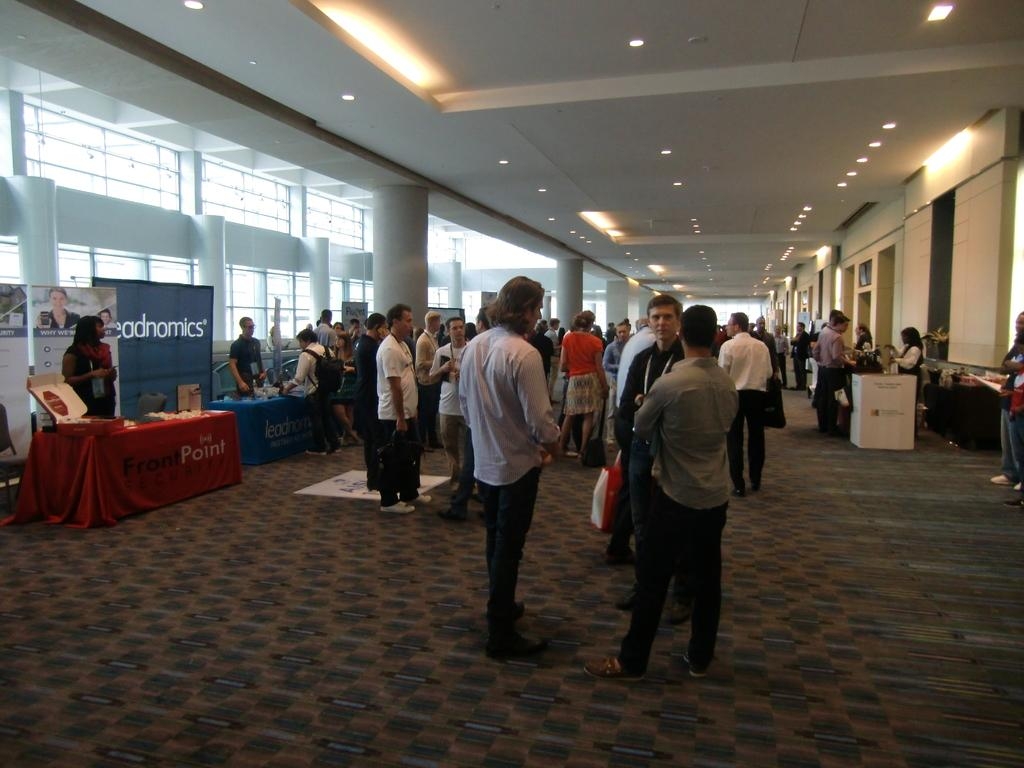What type of space is depicted in the image? There is a big hall in the image. How many people are present in the hall? There are many people in the hall. What furniture can be seen in the hall? There are tables and chairs in the hall. What decorations are present in the hall? There are banners in the hall. What is the lighting situation in the hall? There is a roof with lights in the hall. What type of flooring is in the hall? There is a carpet in the hall. What type of head apparatus is visible on the people in the image? There is no mention of any head apparatus in the image; people are simply present in the hall. 